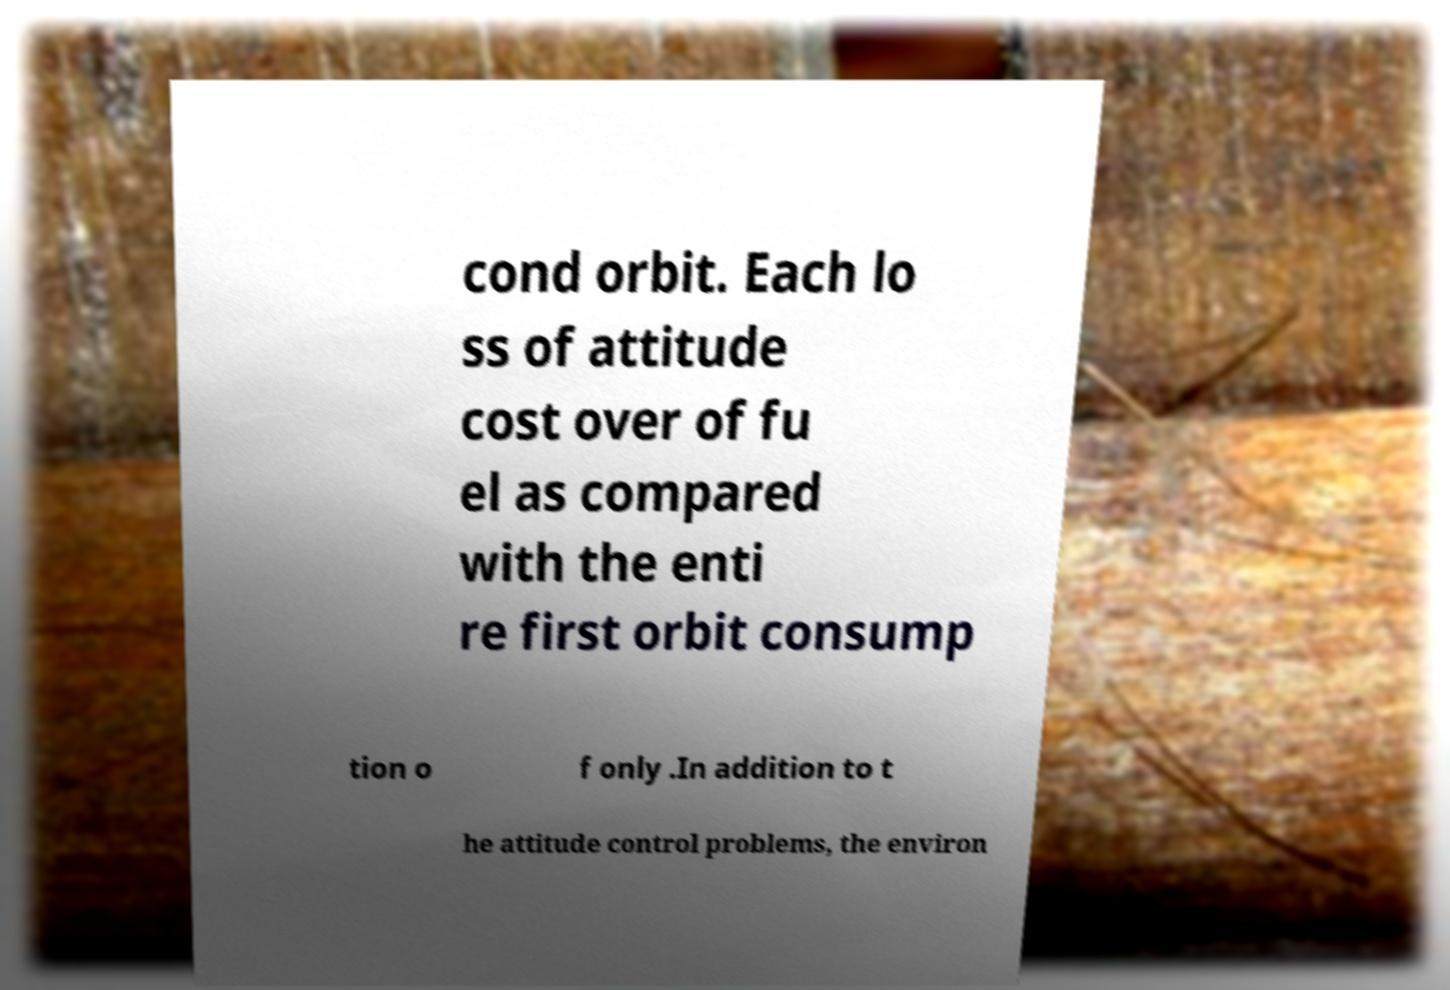Please read and relay the text visible in this image. What does it say? cond orbit. Each lo ss of attitude cost over of fu el as compared with the enti re first orbit consump tion o f only .In addition to t he attitude control problems, the environ 